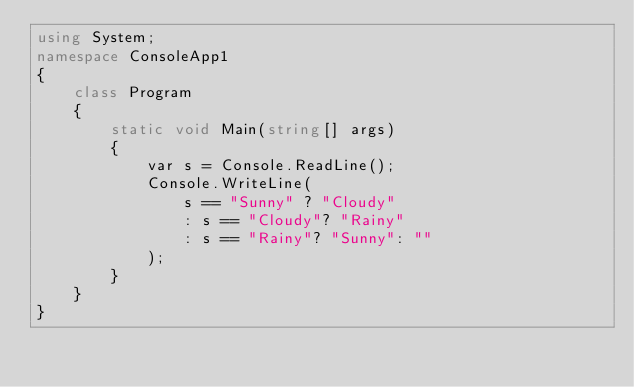Convert code to text. <code><loc_0><loc_0><loc_500><loc_500><_C#_>using System;
namespace ConsoleApp1
{
    class Program
    {
        static void Main(string[] args)
        {
            var s = Console.ReadLine();
            Console.WriteLine(
                s == "Sunny" ? "Cloudy" 
                : s == "Cloudy"? "Rainy"
                : s == "Rainy"? "Sunny": ""
            );
        }
    }
}
</code> 